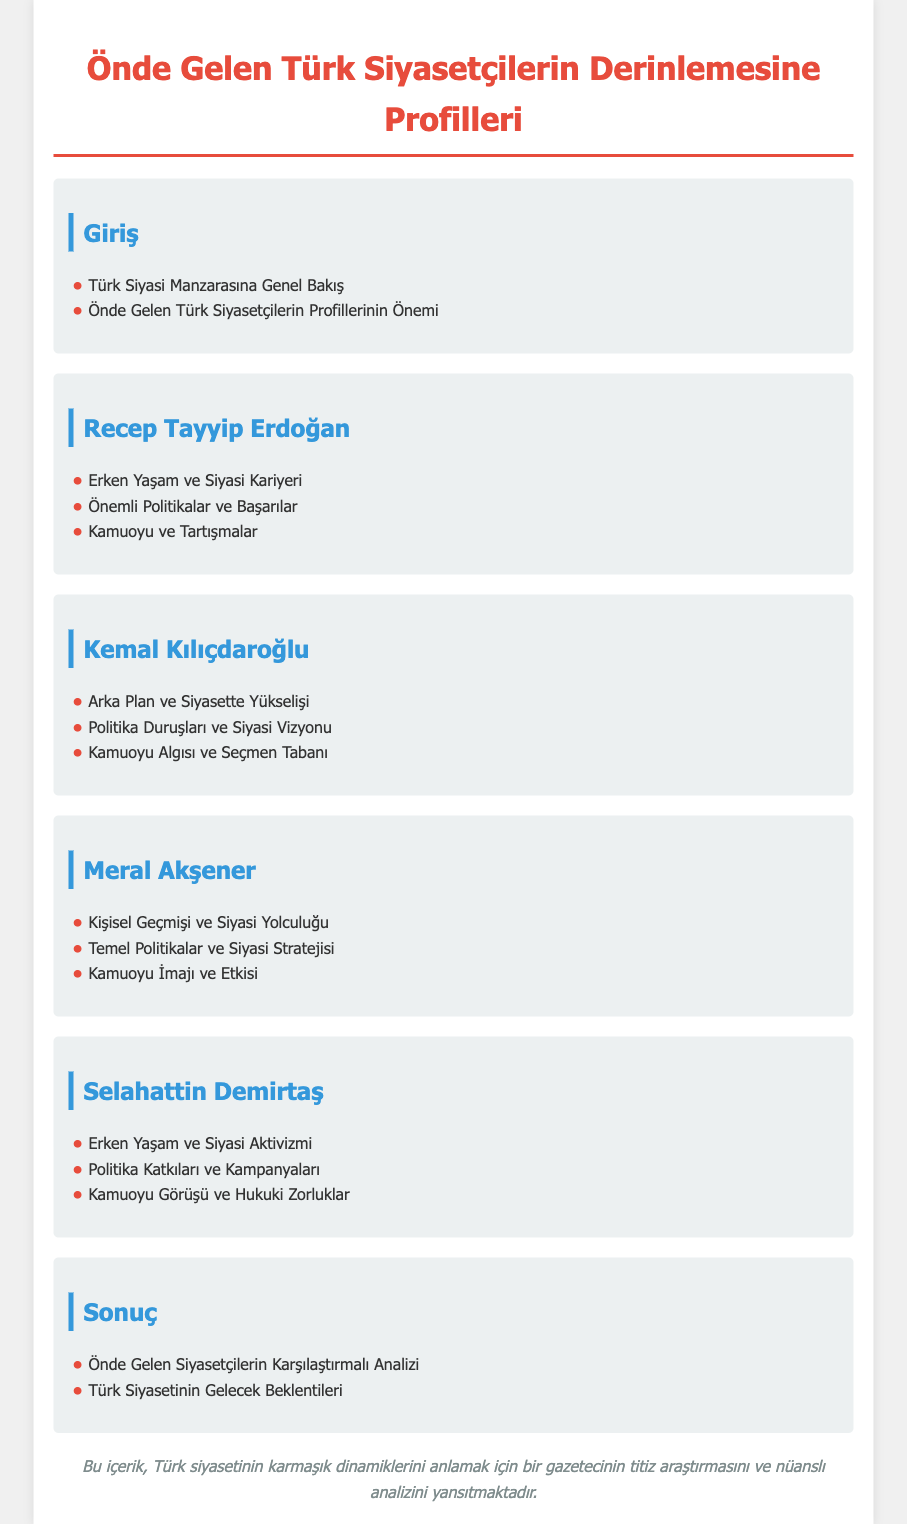what is the main title of the document? The main title is prominently displayed at the top of the document, indicating its subject matter.
Answer: Önde Gelen Türk Siyasetçilerin Derinlemesine Profilleri who is the first politician profiled in the document? The first politician listed in the index section is identified by their name.
Answer: Recep Tayyip Erdoğan what is the focus of Selahattin Demirtaş's section? This section includes specific aspects of Selahattin Demirtaş's life and career as described in the document.
Answer: Erken Yaşam ve Siyasi Aktivizmi how many sections are dedicated to individual politicians? The number of sections is counted based on the given document structure.
Answer: Four what is the last topic discussed in the document? This question identifies the final subject of analysis presented in the conclusion section.
Answer: Türk Siyasetinin Gelecek Beklentileri 